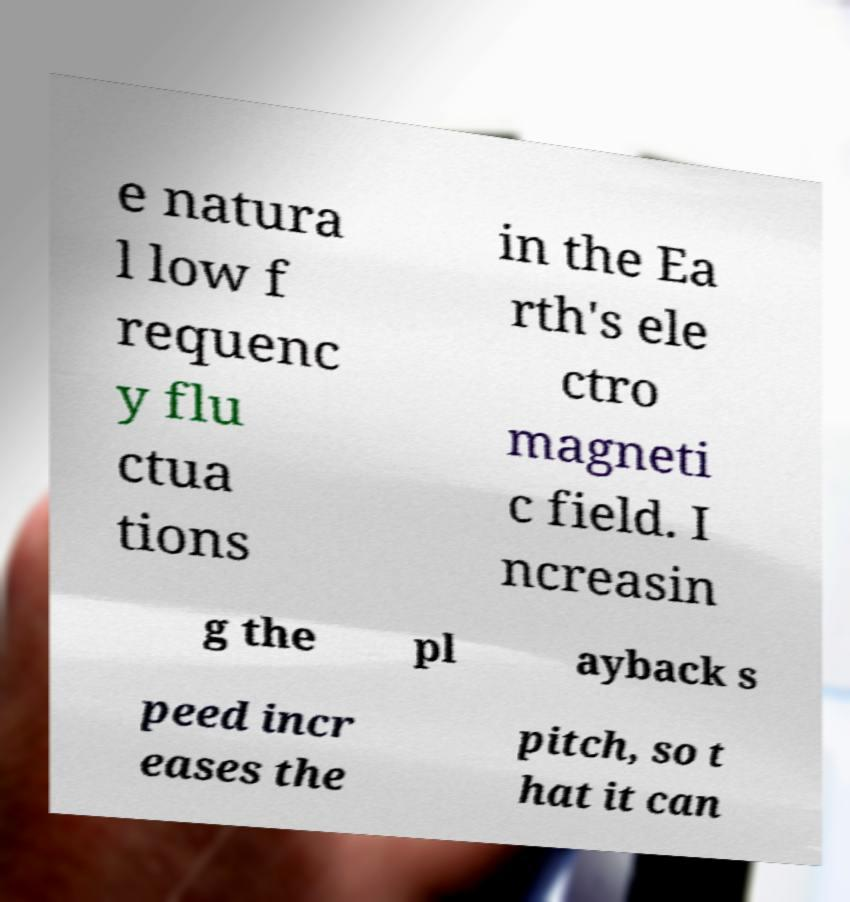Can you accurately transcribe the text from the provided image for me? e natura l low f requenc y flu ctua tions in the Ea rth's ele ctro magneti c field. I ncreasin g the pl ayback s peed incr eases the pitch, so t hat it can 